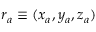<formula> <loc_0><loc_0><loc_500><loc_500>r _ { a } \equiv ( x _ { a } , y _ { a } , z _ { a } )</formula> 